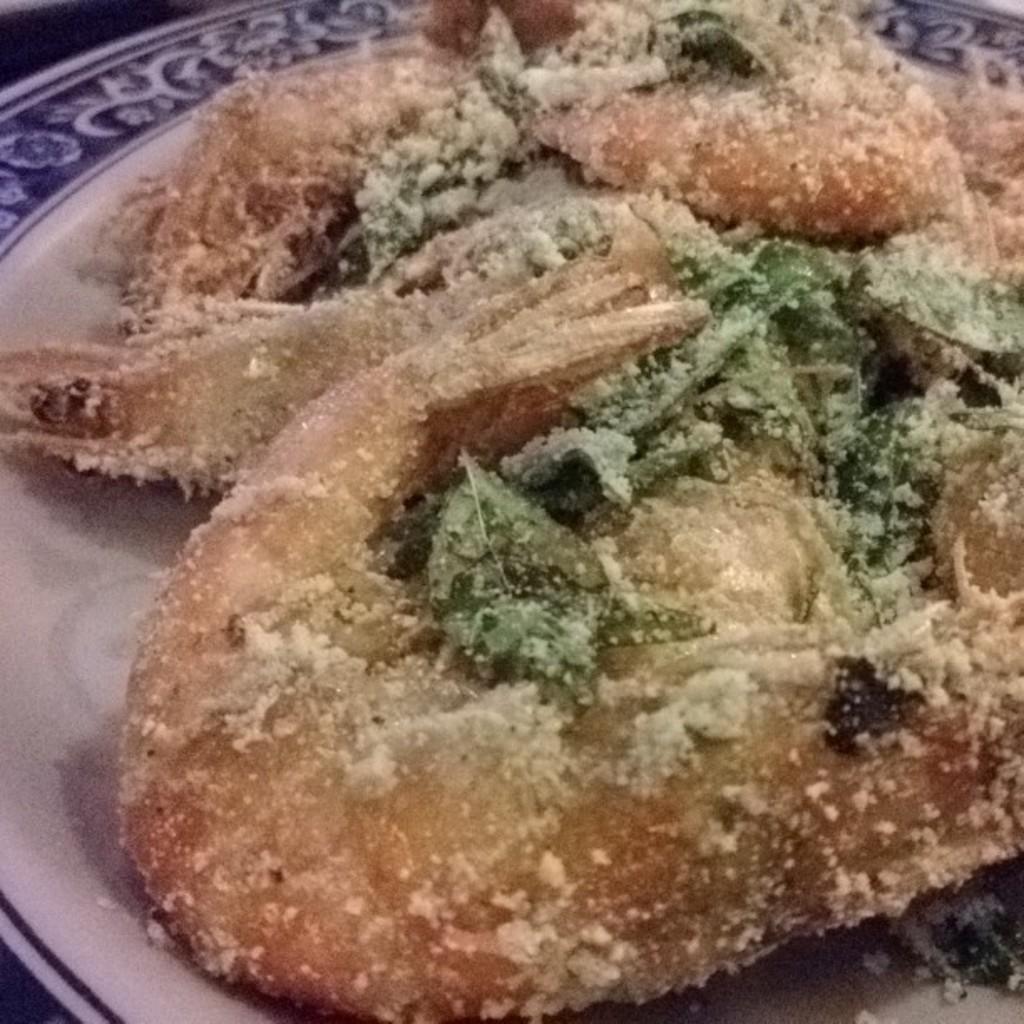In one or two sentences, can you explain what this image depicts? In this picture we can see a plate at the bottom, there is some food present in this plate. 